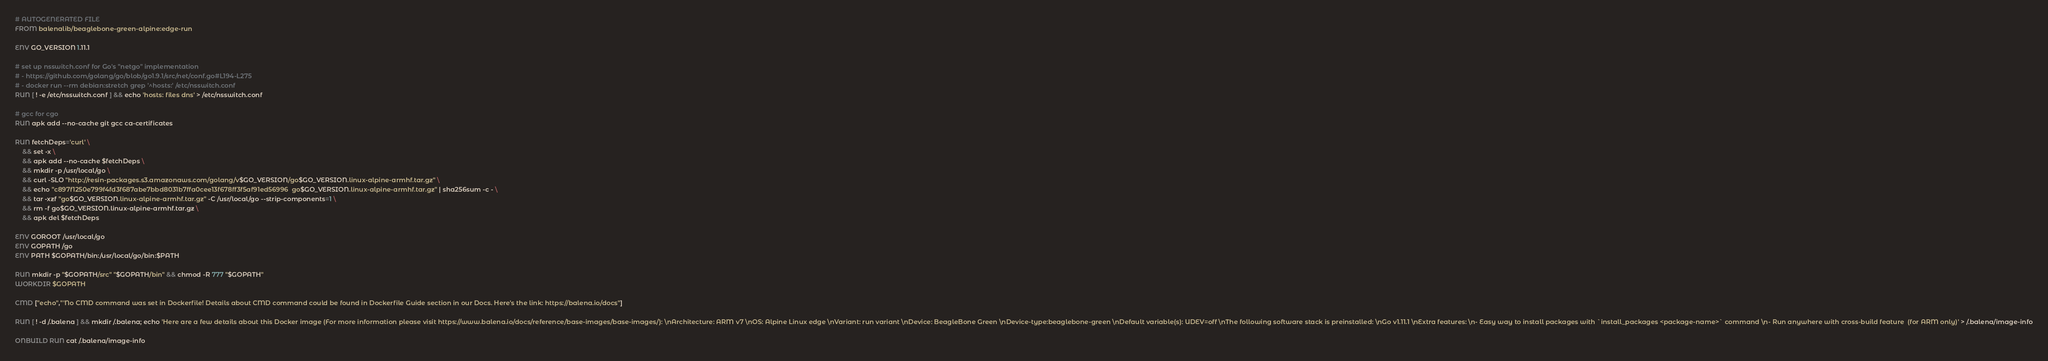<code> <loc_0><loc_0><loc_500><loc_500><_Dockerfile_># AUTOGENERATED FILE
FROM balenalib/beaglebone-green-alpine:edge-run

ENV GO_VERSION 1.11.1

# set up nsswitch.conf for Go's "netgo" implementation
# - https://github.com/golang/go/blob/go1.9.1/src/net/conf.go#L194-L275
# - docker run --rm debian:stretch grep '^hosts:' /etc/nsswitch.conf
RUN [ ! -e /etc/nsswitch.conf ] && echo 'hosts: files dns' > /etc/nsswitch.conf

# gcc for cgo
RUN apk add --no-cache git gcc ca-certificates

RUN fetchDeps='curl' \
	&& set -x \
	&& apk add --no-cache $fetchDeps \
	&& mkdir -p /usr/local/go \
	&& curl -SLO "http://resin-packages.s3.amazonaws.com/golang/v$GO_VERSION/go$GO_VERSION.linux-alpine-armhf.tar.gz" \
	&& echo "c897f1250e799f4fd3f687abe7bbd8031b7ffa0cee13f678ff3f5af91ed56996  go$GO_VERSION.linux-alpine-armhf.tar.gz" | sha256sum -c - \
	&& tar -xzf "go$GO_VERSION.linux-alpine-armhf.tar.gz" -C /usr/local/go --strip-components=1 \
	&& rm -f go$GO_VERSION.linux-alpine-armhf.tar.gz \
	&& apk del $fetchDeps

ENV GOROOT /usr/local/go
ENV GOPATH /go
ENV PATH $GOPATH/bin:/usr/local/go/bin:$PATH

RUN mkdir -p "$GOPATH/src" "$GOPATH/bin" && chmod -R 777 "$GOPATH"
WORKDIR $GOPATH

CMD ["echo","'No CMD command was set in Dockerfile! Details about CMD command could be found in Dockerfile Guide section in our Docs. Here's the link: https://balena.io/docs"]

RUN [ ! -d /.balena ] && mkdir /.balena; echo 'Here are a few details about this Docker image (For more information please visit https://www.balena.io/docs/reference/base-images/base-images/): \nArchitecture: ARM v7 \nOS: Alpine Linux edge \nVariant: run variant \nDevice: BeagleBone Green \nDevice-type:beaglebone-green \nDefault variable(s): UDEV=off \nThe following software stack is preinstalled: \nGo v1.11.1 \nExtra features: \n- Easy way to install packages with `install_packages <package-name>` command \n- Run anywhere with cross-build feature  (for ARM only)' > /.balena/image-info

ONBUILD RUN cat /.balena/image-info</code> 